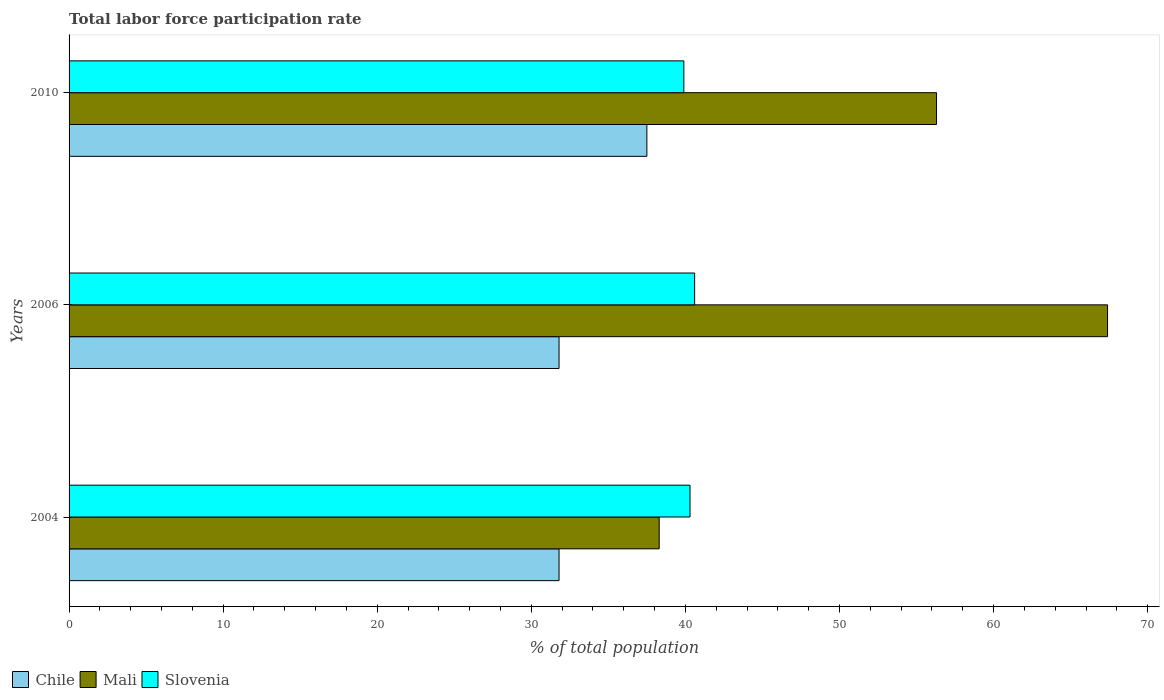How many different coloured bars are there?
Offer a very short reply. 3. How many groups of bars are there?
Your answer should be very brief. 3. Are the number of bars per tick equal to the number of legend labels?
Your response must be concise. Yes. Are the number of bars on each tick of the Y-axis equal?
Ensure brevity in your answer.  Yes. How many bars are there on the 3rd tick from the top?
Offer a very short reply. 3. In how many cases, is the number of bars for a given year not equal to the number of legend labels?
Your response must be concise. 0. What is the total labor force participation rate in Chile in 2006?
Make the answer very short. 31.8. Across all years, what is the maximum total labor force participation rate in Slovenia?
Your answer should be very brief. 40.6. Across all years, what is the minimum total labor force participation rate in Slovenia?
Make the answer very short. 39.9. What is the total total labor force participation rate in Mali in the graph?
Ensure brevity in your answer.  162. What is the difference between the total labor force participation rate in Mali in 2004 and that in 2010?
Provide a succinct answer. -18. What is the difference between the total labor force participation rate in Chile in 2006 and the total labor force participation rate in Mali in 2010?
Your response must be concise. -24.5. What is the average total labor force participation rate in Slovenia per year?
Offer a terse response. 40.27. In the year 2010, what is the difference between the total labor force participation rate in Mali and total labor force participation rate in Slovenia?
Your answer should be compact. 16.4. What is the ratio of the total labor force participation rate in Mali in 2004 to that in 2006?
Keep it short and to the point. 0.57. Is the total labor force participation rate in Mali in 2004 less than that in 2006?
Offer a very short reply. Yes. Is the difference between the total labor force participation rate in Mali in 2006 and 2010 greater than the difference between the total labor force participation rate in Slovenia in 2006 and 2010?
Keep it short and to the point. Yes. What is the difference between the highest and the second highest total labor force participation rate in Chile?
Offer a terse response. 5.7. What is the difference between the highest and the lowest total labor force participation rate in Chile?
Provide a short and direct response. 5.7. Is the sum of the total labor force participation rate in Mali in 2006 and 2010 greater than the maximum total labor force participation rate in Chile across all years?
Offer a very short reply. Yes. What does the 2nd bar from the top in 2010 represents?
Keep it short and to the point. Mali. What does the 1st bar from the bottom in 2010 represents?
Your answer should be very brief. Chile. Are all the bars in the graph horizontal?
Provide a succinct answer. Yes. What is the difference between two consecutive major ticks on the X-axis?
Your answer should be compact. 10. Does the graph contain any zero values?
Your answer should be very brief. No. Where does the legend appear in the graph?
Provide a succinct answer. Bottom left. How many legend labels are there?
Give a very brief answer. 3. What is the title of the graph?
Your answer should be compact. Total labor force participation rate. Does "Sub-Saharan Africa (all income levels)" appear as one of the legend labels in the graph?
Offer a very short reply. No. What is the label or title of the X-axis?
Provide a short and direct response. % of total population. What is the % of total population in Chile in 2004?
Ensure brevity in your answer.  31.8. What is the % of total population of Mali in 2004?
Provide a short and direct response. 38.3. What is the % of total population of Slovenia in 2004?
Your answer should be compact. 40.3. What is the % of total population of Chile in 2006?
Offer a terse response. 31.8. What is the % of total population of Mali in 2006?
Provide a succinct answer. 67.4. What is the % of total population of Slovenia in 2006?
Your answer should be compact. 40.6. What is the % of total population of Chile in 2010?
Make the answer very short. 37.5. What is the % of total population in Mali in 2010?
Provide a succinct answer. 56.3. What is the % of total population of Slovenia in 2010?
Keep it short and to the point. 39.9. Across all years, what is the maximum % of total population in Chile?
Your answer should be compact. 37.5. Across all years, what is the maximum % of total population in Mali?
Offer a terse response. 67.4. Across all years, what is the maximum % of total population of Slovenia?
Make the answer very short. 40.6. Across all years, what is the minimum % of total population in Chile?
Give a very brief answer. 31.8. Across all years, what is the minimum % of total population of Mali?
Offer a very short reply. 38.3. Across all years, what is the minimum % of total population of Slovenia?
Give a very brief answer. 39.9. What is the total % of total population of Chile in the graph?
Your response must be concise. 101.1. What is the total % of total population in Mali in the graph?
Your response must be concise. 162. What is the total % of total population of Slovenia in the graph?
Ensure brevity in your answer.  120.8. What is the difference between the % of total population in Mali in 2004 and that in 2006?
Provide a succinct answer. -29.1. What is the difference between the % of total population in Slovenia in 2004 and that in 2006?
Provide a short and direct response. -0.3. What is the difference between the % of total population of Mali in 2004 and that in 2010?
Give a very brief answer. -18. What is the difference between the % of total population in Chile in 2004 and the % of total population in Mali in 2006?
Your response must be concise. -35.6. What is the difference between the % of total population in Chile in 2004 and the % of total population in Slovenia in 2006?
Ensure brevity in your answer.  -8.8. What is the difference between the % of total population in Mali in 2004 and the % of total population in Slovenia in 2006?
Make the answer very short. -2.3. What is the difference between the % of total population of Chile in 2004 and the % of total population of Mali in 2010?
Give a very brief answer. -24.5. What is the difference between the % of total population in Mali in 2004 and the % of total population in Slovenia in 2010?
Ensure brevity in your answer.  -1.6. What is the difference between the % of total population in Chile in 2006 and the % of total population in Mali in 2010?
Offer a very short reply. -24.5. What is the difference between the % of total population of Chile in 2006 and the % of total population of Slovenia in 2010?
Offer a very short reply. -8.1. What is the difference between the % of total population of Mali in 2006 and the % of total population of Slovenia in 2010?
Offer a terse response. 27.5. What is the average % of total population of Chile per year?
Your answer should be very brief. 33.7. What is the average % of total population in Slovenia per year?
Keep it short and to the point. 40.27. In the year 2004, what is the difference between the % of total population in Chile and % of total population in Mali?
Offer a very short reply. -6.5. In the year 2004, what is the difference between the % of total population in Chile and % of total population in Slovenia?
Your response must be concise. -8.5. In the year 2006, what is the difference between the % of total population in Chile and % of total population in Mali?
Your answer should be very brief. -35.6. In the year 2006, what is the difference between the % of total population in Chile and % of total population in Slovenia?
Provide a succinct answer. -8.8. In the year 2006, what is the difference between the % of total population in Mali and % of total population in Slovenia?
Offer a very short reply. 26.8. In the year 2010, what is the difference between the % of total population of Chile and % of total population of Mali?
Give a very brief answer. -18.8. In the year 2010, what is the difference between the % of total population of Mali and % of total population of Slovenia?
Provide a succinct answer. 16.4. What is the ratio of the % of total population in Mali in 2004 to that in 2006?
Your response must be concise. 0.57. What is the ratio of the % of total population in Chile in 2004 to that in 2010?
Offer a terse response. 0.85. What is the ratio of the % of total population in Mali in 2004 to that in 2010?
Ensure brevity in your answer.  0.68. What is the ratio of the % of total population in Chile in 2006 to that in 2010?
Make the answer very short. 0.85. What is the ratio of the % of total population of Mali in 2006 to that in 2010?
Offer a terse response. 1.2. What is the ratio of the % of total population of Slovenia in 2006 to that in 2010?
Offer a very short reply. 1.02. What is the difference between the highest and the second highest % of total population of Chile?
Keep it short and to the point. 5.7. What is the difference between the highest and the lowest % of total population of Chile?
Keep it short and to the point. 5.7. What is the difference between the highest and the lowest % of total population in Mali?
Your response must be concise. 29.1. What is the difference between the highest and the lowest % of total population in Slovenia?
Provide a short and direct response. 0.7. 